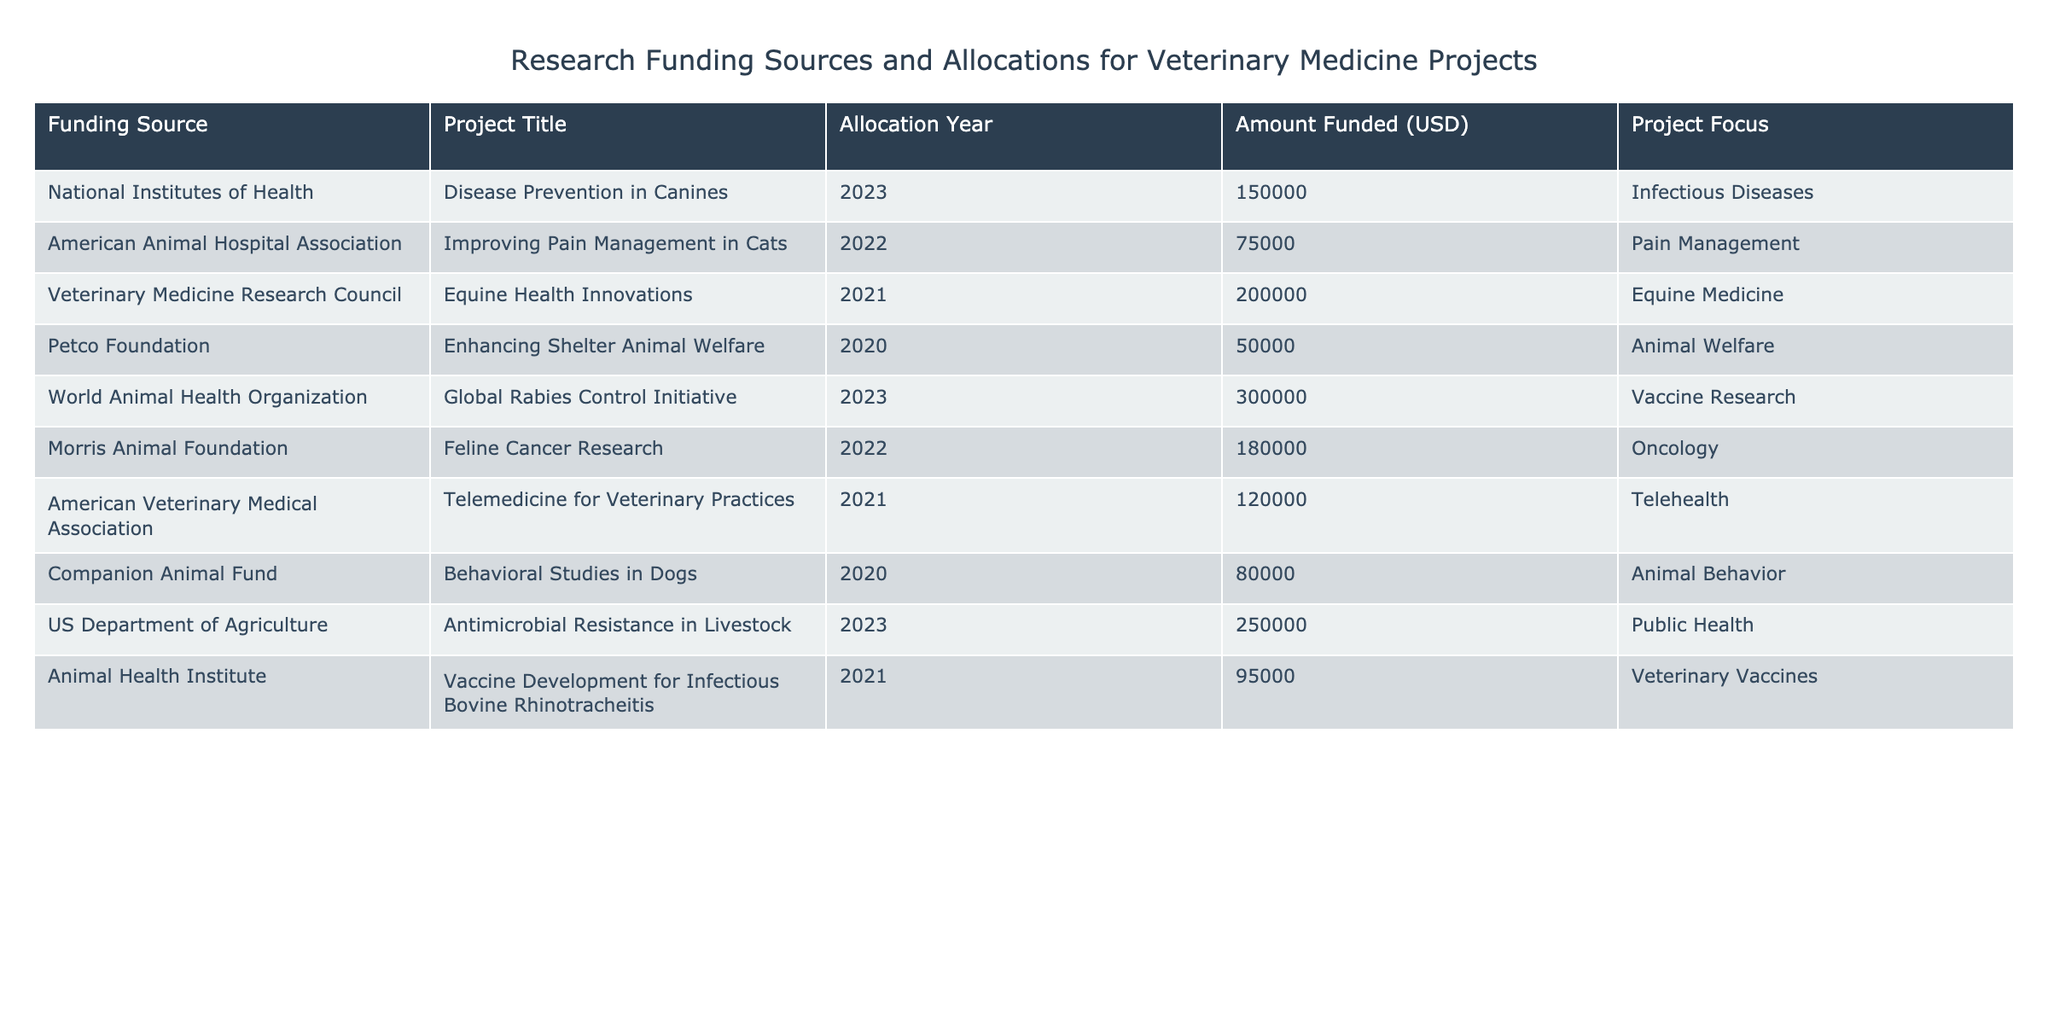What is the total amount funded in 2023? The amounts funded in 2023 are from the National Institutes of Health (150000 USD) and the US Department of Agriculture (250000 USD). Summing these amounts gives 150000 + 250000 = 400000 USD.
Answer: 400000 USD Which project received the highest amount of funding? The project with the highest funding is the Global Rabies Control Initiative funded by the World Animal Health Organization in 2023, with an allocation of 300000 USD.
Answer: Global Rabies Control Initiative How many projects focused on Infectious Diseases? The table lists two projects focusing on Infectious Diseases: Disease Prevention in Canines (2023) from the National Institutes of Health and Vaccine Development for Infectious Bovine Rhinotracheitis (2021) from the Animal Health Institute. Thus, there are 2 projects.
Answer: 2 Is there any funding project that focuses on Animal Welfare? Yes, there is one project focusing on Animal Welfare, which is Enhancing Shelter Animal Welfare funded by the Petco Foundation in 2020.
Answer: Yes What was the average funding amount for projects in 2021? The funding amounts for projects in 2021 are 200000 USD (Equine Health Innovations), 120000 USD (Telemedicine for Veterinary Practices), and 95000 USD (Vaccine Development for Infectious Bovine Rhinotracheitis). Summing these gives 200000 + 120000 + 95000 = 415000 USD. Dividing this by the number of projects (3) gives an average of 415000 / 3 = 138333.33 USD.
Answer: 138333.33 USD Which funding source contributed to a project in both 2022 and 2023? The funding sources for 2022 are the American Animal Hospital Association (75000 USD) and Morris Animal Foundation (180000 USD). For 2023, we have the National Institutes of Health (150000 USD), the World Animal Health Organization (300000 USD), and the US Department of Agriculture (250000 USD). Therefore, no funding source contributed to projects in both 2022 and 2023.
Answer: No What is the total funding received from the American Veterinary Medical Association and the Morris Animal Foundation? The American Veterinary Medical Association funded 120000 USD for Telemedicine for Veterinary Practices in 2021, and the Morris Animal Foundation funded 180000 USD for Feline Cancer Research in 2022. Adding these amounts gives 120000 + 180000 = 300000 USD.
Answer: 300000 USD How many projects were funded by the US Department of Agriculture? The US Department of Agriculture funded one project: Antimicrobial Resistance in Livestock in 2023.
Answer: 1 Which project was allocated funding in 2020? The table shows one project allocated funding in 2020, which is Enhancing Shelter Animal Welfare funded by the Petco Foundation.
Answer: Enhancing Shelter Animal Welfare 